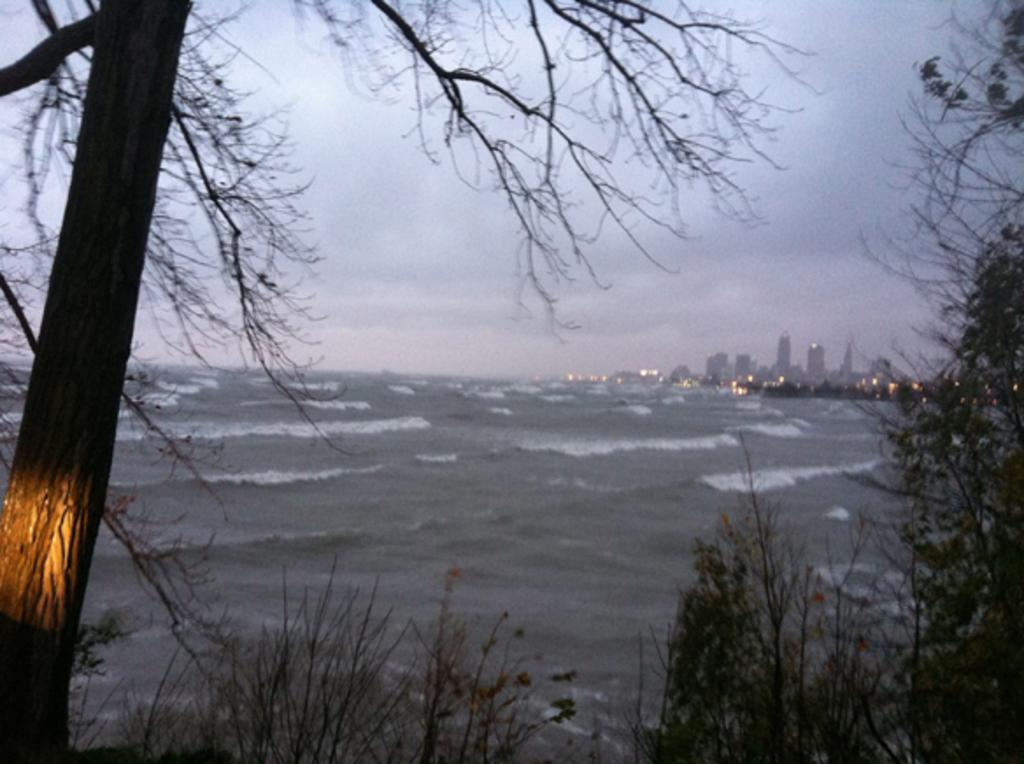What type of natural elements can be seen in the image? There are trees and water waves visible in the image. What type of structures can be seen in the background of the image? There are buildings in the background of the image. What is visible in the sky in the background of the image? Clouds are present in the sky in the background of the image. What color is the dress worn by the person in the image? There is no person wearing a dress present in the image. What day of the week is depicted in the image? The image does not depict a specific day of the week. 